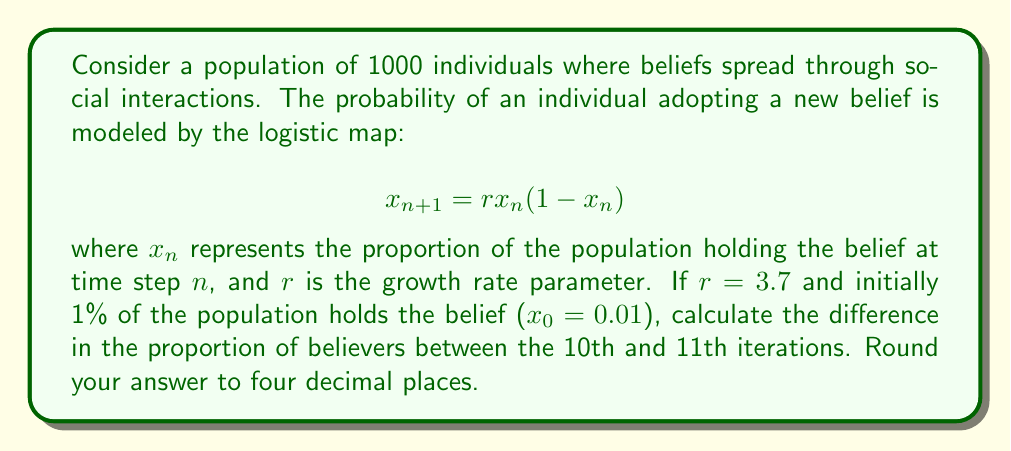Provide a solution to this math problem. To solve this problem, we need to iterate the logistic map equation for 11 steps and compare the results of the 10th and 11th iterations. Let's break it down step-by-step:

1. Given: $r = 3.7$, $x_0 = 0.01$

2. We need to calculate $x_1$ through $x_{11}$ using the formula:
   $$x_{n+1} = 3.7x_n(1-x_n)$$

3. Let's calculate each iteration:
   $x_1 = 3.7(0.01)(1-0.01) = 0.03663$
   $x_2 = 3.7(0.03663)(1-0.03663) = 0.13039$
   $x_3 = 3.7(0.13039)(1-0.13039) = 0.41899$
   $x_4 = 3.7(0.41899)(1-0.41899) = 0.90047$
   $x_5 = 3.7(0.90047)(1-0.90047) = 0.33261$
   $x_6 = 3.7(0.33261)(1-0.33261) = 0.82225$
   $x_7 = 3.7(0.82225)(1-0.82225) = 0.54078$
   $x_8 = 3.7(0.54078)(1-0.54078) = 0.91901$
   $x_9 = 3.7(0.91901)(1-0.91901) = 0.27545$
   $x_{10} = 3.7(0.27545)(1-0.27545) = 0.73799$
   $x_{11} = 3.7(0.73799)(1-0.73799) = 0.71601$

4. The difference between the 11th and 10th iterations is:
   $x_{11} - x_{10} = 0.71601 - 0.73799 = -0.02198$

5. Rounding to four decimal places: -0.0220

This result demonstrates the butterfly effect in the spread of beliefs. A small initial condition (1% of the population) led to significant fluctuations in belief adoption over time, with the proportion of believers changing by about 2.20% between just two consecutive iterations after 10 steps.
Answer: -0.0220 